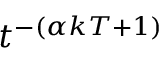Convert formula to latex. <formula><loc_0><loc_0><loc_500><loc_500>t ^ { - ( \alpha k T + 1 ) }</formula> 